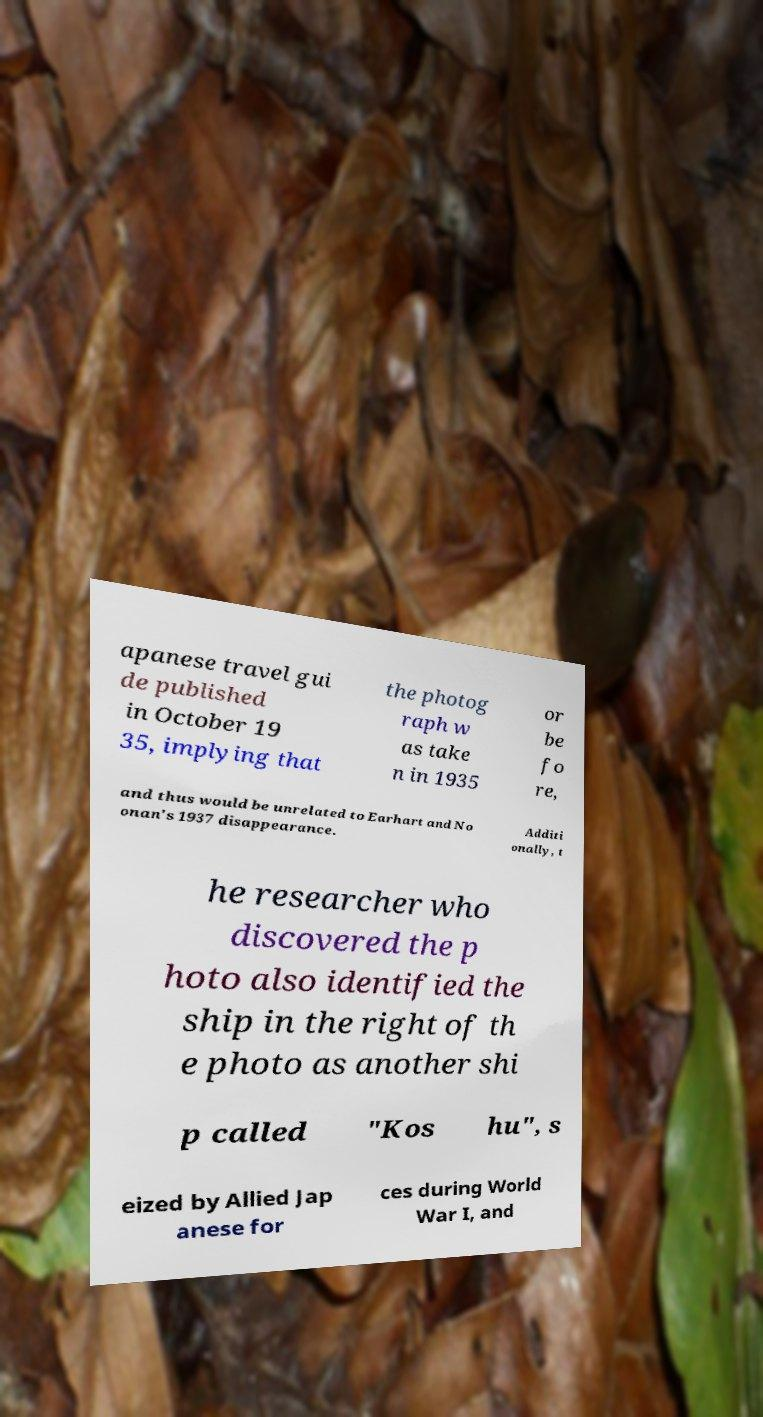Could you assist in decoding the text presented in this image and type it out clearly? apanese travel gui de published in October 19 35, implying that the photog raph w as take n in 1935 or be fo re, and thus would be unrelated to Earhart and No onan's 1937 disappearance. Additi onally, t he researcher who discovered the p hoto also identified the ship in the right of th e photo as another shi p called "Kos hu", s eized by Allied Jap anese for ces during World War I, and 